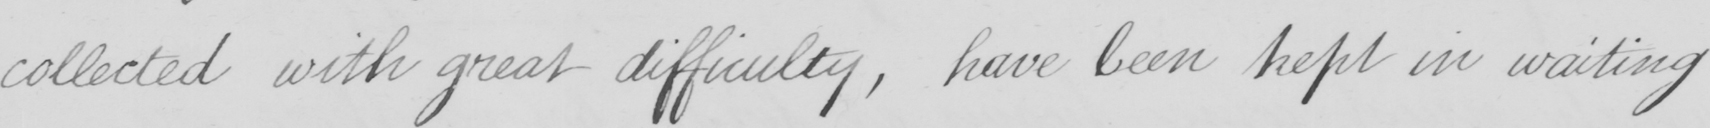Please provide the text content of this handwritten line. collected with great difficulty , have been kept in waiting 